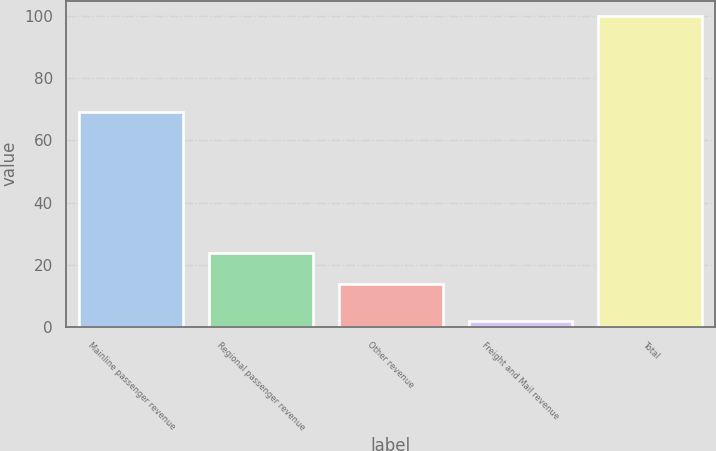Convert chart. <chart><loc_0><loc_0><loc_500><loc_500><bar_chart><fcel>Mainline passenger revenue<fcel>Regional passenger revenue<fcel>Other revenue<fcel>Freight and Mail revenue<fcel>Total<nl><fcel>69<fcel>23.8<fcel>14<fcel>2<fcel>100<nl></chart> 